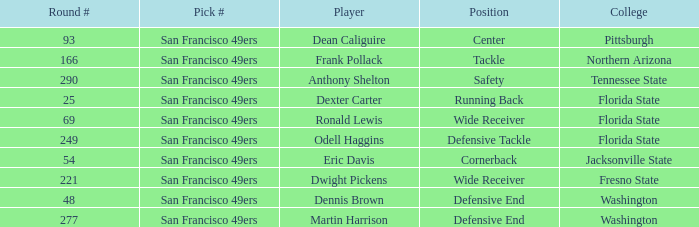What is the College with a Round # that is 290? Tennessee State. 